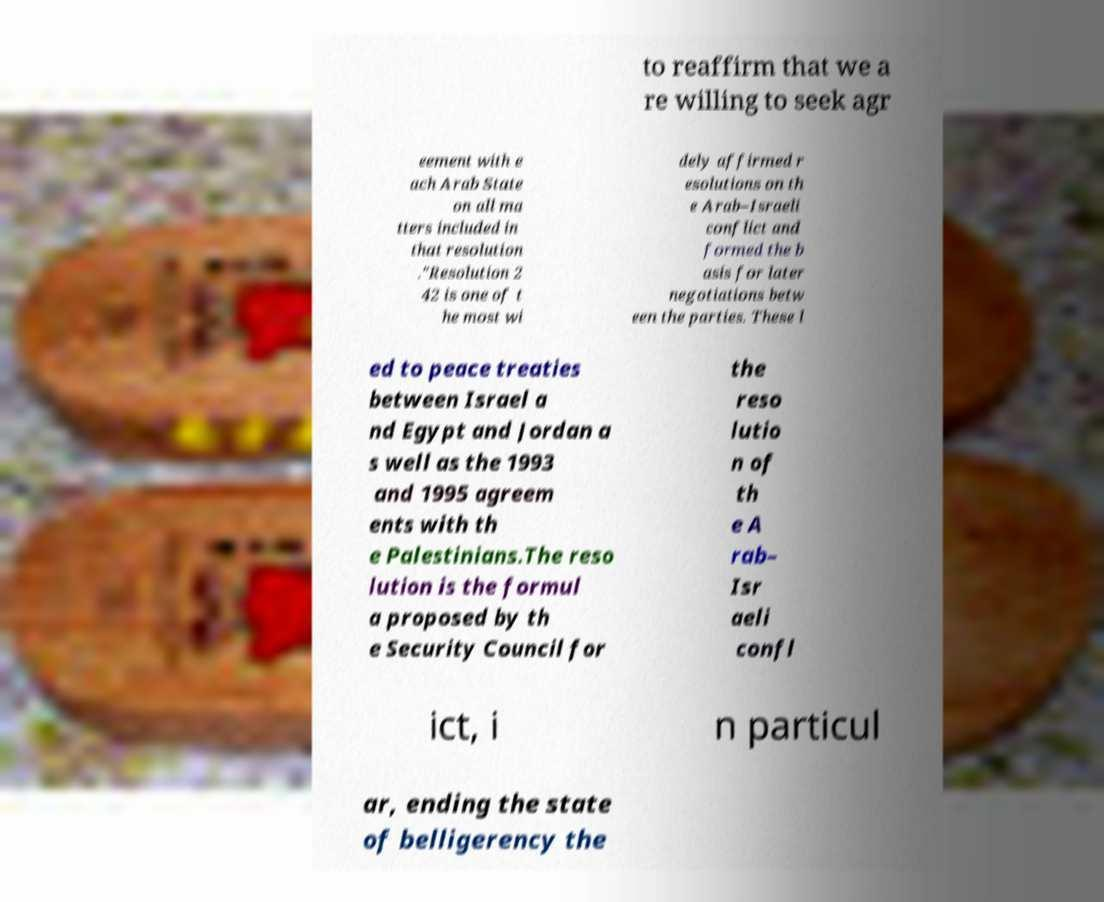Please read and relay the text visible in this image. What does it say? to reaffirm that we a re willing to seek agr eement with e ach Arab State on all ma tters included in that resolution ."Resolution 2 42 is one of t he most wi dely affirmed r esolutions on th e Arab–Israeli conflict and formed the b asis for later negotiations betw een the parties. These l ed to peace treaties between Israel a nd Egypt and Jordan a s well as the 1993 and 1995 agreem ents with th e Palestinians.The reso lution is the formul a proposed by th e Security Council for the reso lutio n of th e A rab– Isr aeli confl ict, i n particul ar, ending the state of belligerency the 